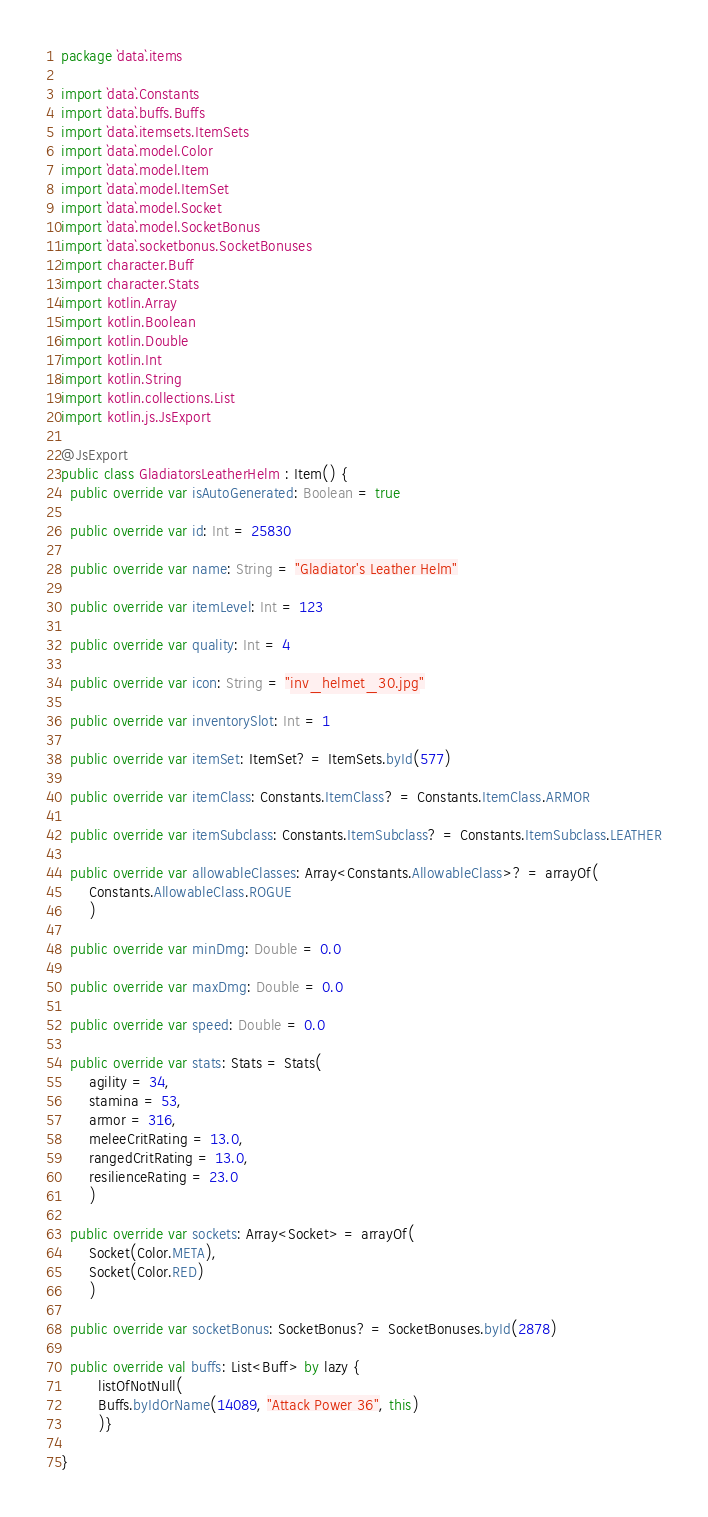<code> <loc_0><loc_0><loc_500><loc_500><_Kotlin_>package `data`.items

import `data`.Constants
import `data`.buffs.Buffs
import `data`.itemsets.ItemSets
import `data`.model.Color
import `data`.model.Item
import `data`.model.ItemSet
import `data`.model.Socket
import `data`.model.SocketBonus
import `data`.socketbonus.SocketBonuses
import character.Buff
import character.Stats
import kotlin.Array
import kotlin.Boolean
import kotlin.Double
import kotlin.Int
import kotlin.String
import kotlin.collections.List
import kotlin.js.JsExport

@JsExport
public class GladiatorsLeatherHelm : Item() {
  public override var isAutoGenerated: Boolean = true

  public override var id: Int = 25830

  public override var name: String = "Gladiator's Leather Helm"

  public override var itemLevel: Int = 123

  public override var quality: Int = 4

  public override var icon: String = "inv_helmet_30.jpg"

  public override var inventorySlot: Int = 1

  public override var itemSet: ItemSet? = ItemSets.byId(577)

  public override var itemClass: Constants.ItemClass? = Constants.ItemClass.ARMOR

  public override var itemSubclass: Constants.ItemSubclass? = Constants.ItemSubclass.LEATHER

  public override var allowableClasses: Array<Constants.AllowableClass>? = arrayOf(
      Constants.AllowableClass.ROGUE
      )

  public override var minDmg: Double = 0.0

  public override var maxDmg: Double = 0.0

  public override var speed: Double = 0.0

  public override var stats: Stats = Stats(
      agility = 34,
      stamina = 53,
      armor = 316,
      meleeCritRating = 13.0,
      rangedCritRating = 13.0,
      resilienceRating = 23.0
      )

  public override var sockets: Array<Socket> = arrayOf(
      Socket(Color.META),
      Socket(Color.RED)
      )

  public override var socketBonus: SocketBonus? = SocketBonuses.byId(2878)

  public override val buffs: List<Buff> by lazy {
        listOfNotNull(
        Buffs.byIdOrName(14089, "Attack Power 36", this)
        )}

}
</code> 